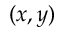<formula> <loc_0><loc_0><loc_500><loc_500>( x , y )</formula> 